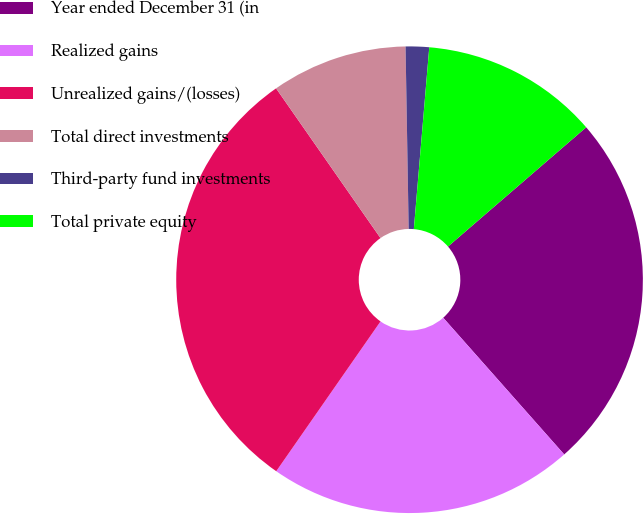Convert chart. <chart><loc_0><loc_0><loc_500><loc_500><pie_chart><fcel>Year ended December 31 (in<fcel>Realized gains<fcel>Unrealized gains/(losses)<fcel>Total direct investments<fcel>Third-party fund investments<fcel>Total private equity<nl><fcel>24.8%<fcel>21.21%<fcel>30.63%<fcel>9.42%<fcel>1.62%<fcel>12.32%<nl></chart> 